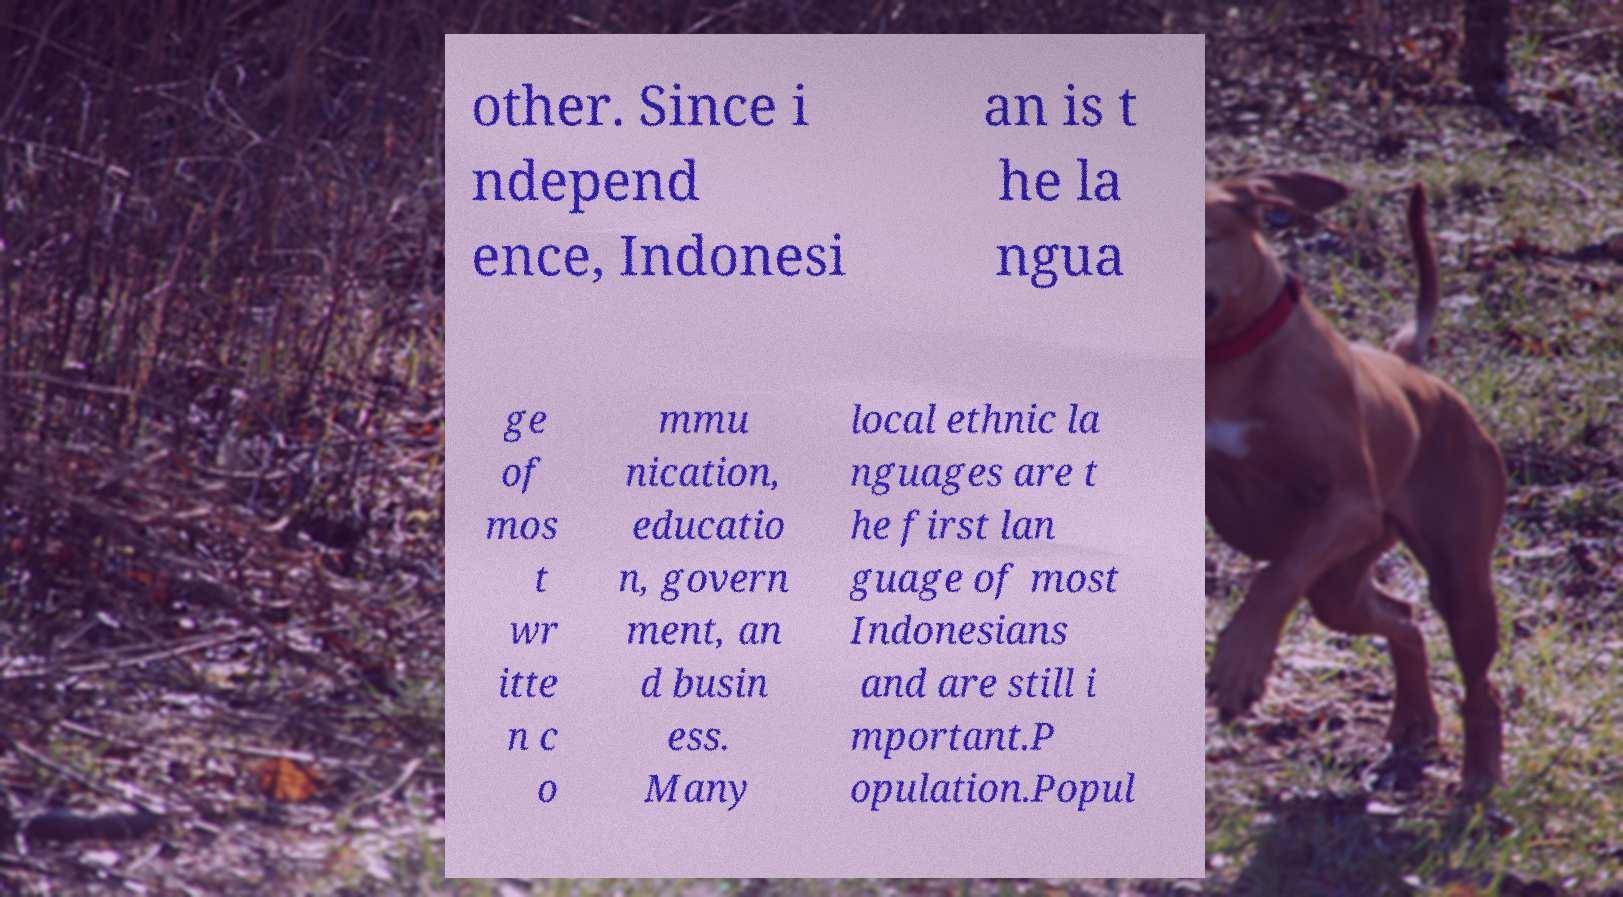Please identify and transcribe the text found in this image. other. Since i ndepend ence, Indonesi an is t he la ngua ge of mos t wr itte n c o mmu nication, educatio n, govern ment, an d busin ess. Many local ethnic la nguages are t he first lan guage of most Indonesians and are still i mportant.P opulation.Popul 